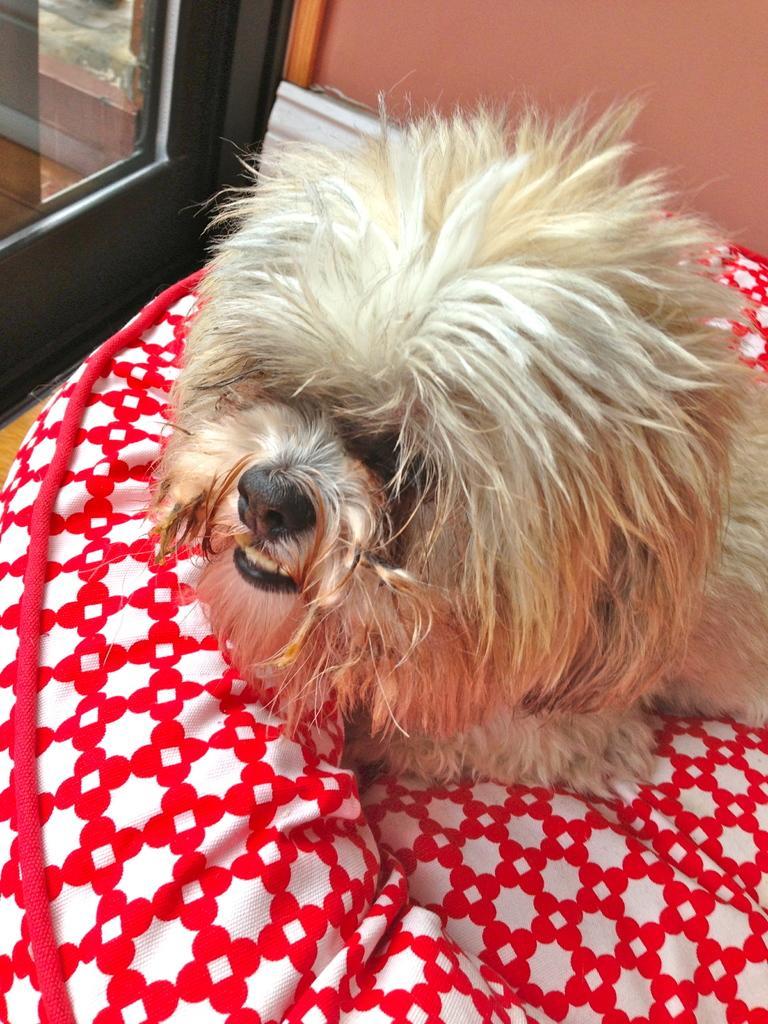In one or two sentences, can you explain what this image depicts? In this picture there is a day on the bed. In the top left corner it might be the door or window. At the top I can see the wall. 